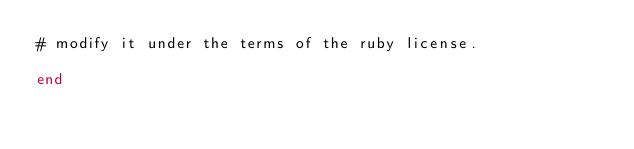Convert code to text. <code><loc_0><loc_0><loc_500><loc_500><_Ruby_># modify it under the terms of the ruby license.

end
</code> 